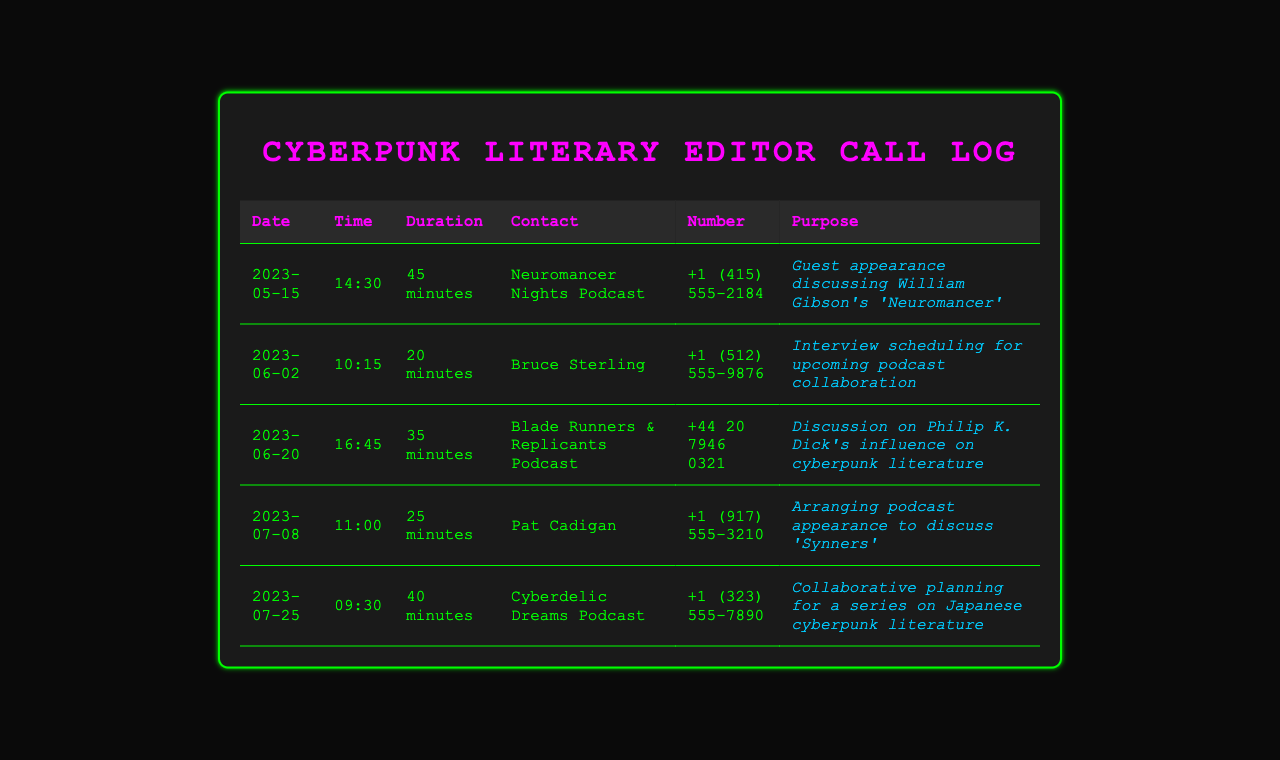What date was the call with Neuromancer Nights Podcast? The date is found in the first row of the table under the "Date" column.
Answer: 2023-05-15 What was the duration of the call with Bruce Sterling? The duration is specified in the second row under the "Duration" column.
Answer: 20 minutes Who did the call on June 20 involve? This information is located in the third row under the "Contact" column.
Answer: Blade Runners & Replicants Podcast What was the purpose of the call with Pat Cadigan? The purpose can be found in the fourth row under the "Purpose" column.
Answer: Arranging podcast appearance to discuss 'Synners' How many minutes did the call with Cyberdelic Dreams Podcast last? The duration is listed in the last row of the table under the "Duration" column.
Answer: 40 minutes Which podcast discussed Philip K. Dick's influence? This can be determined by referring to the entries under "Contact" and "Purpose" columns in the document.
Answer: Blade Runners & Replicants Podcast What is the phone number for the Cyberdelic Dreams Podcast? This specific number is found in the last row under the "Number" column.
Answer: +1 (323) 555-7890 What was the common theme among all calls logged? The calls are related to podcast collaborations and guest appearances within the realm of cyberpunk literature.
Answer: Podcast collaborations How many calls were made to cyberpunk-focused podcasts? The total number can be derived by counting the number of rows in the table, each representing a call made.
Answer: Five 